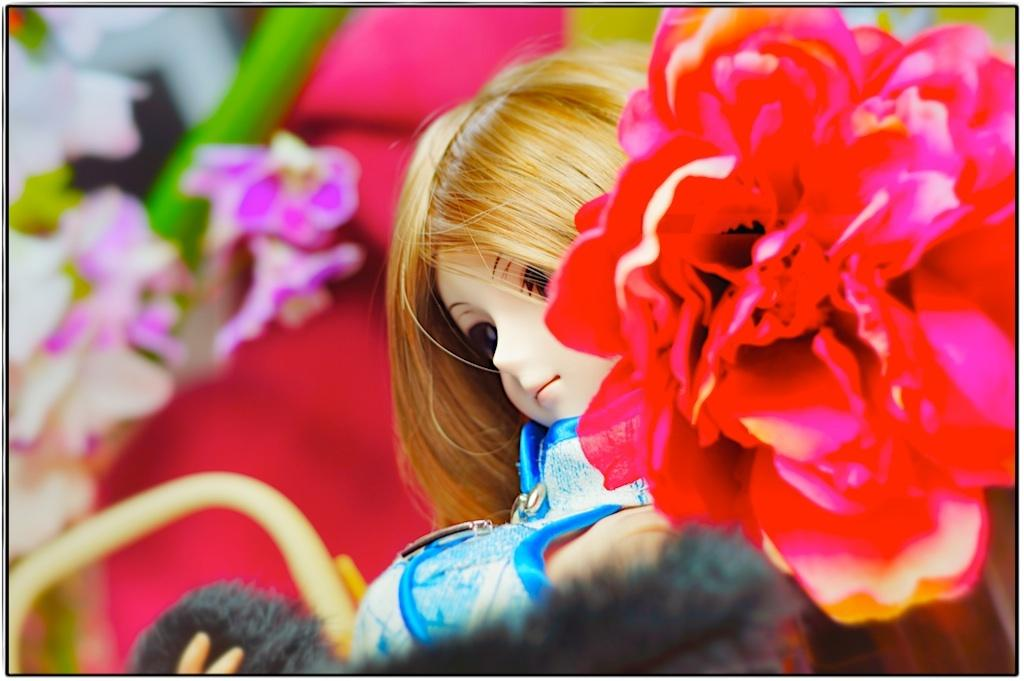What is the main subject of the image? There is a doll in the image. What other objects or elements can be seen in the image? There are flowers in the image. What type of skirt is the doll wearing in the image? The image does not show the doll wearing a skirt, nor does it depict any clothing on the doll. 